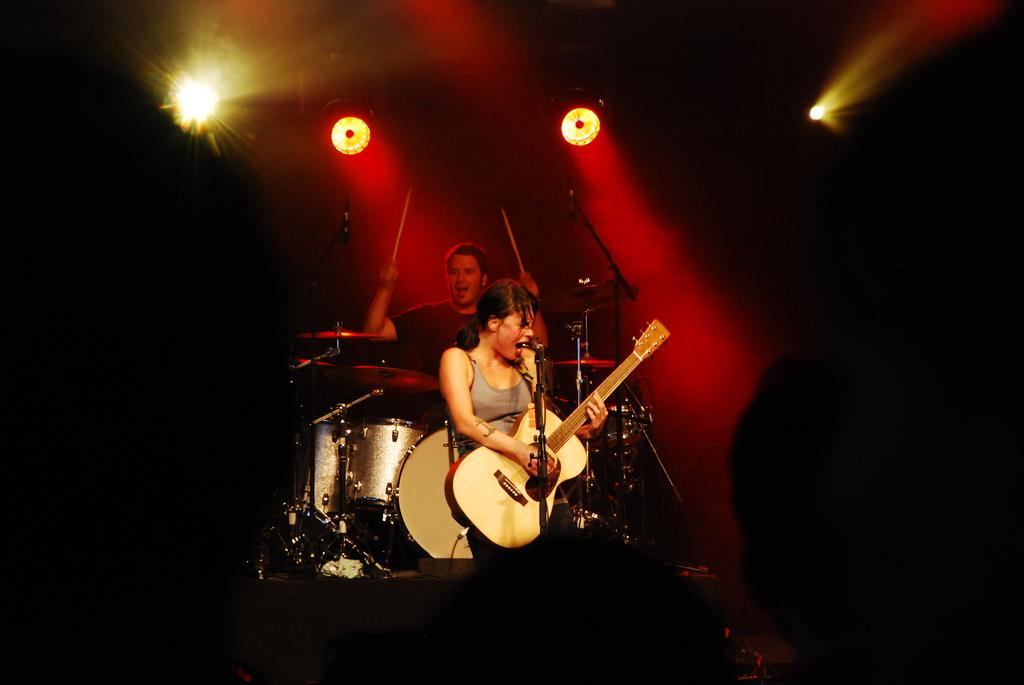What is the woman in the image doing? The woman is standing and singing, and she is holding a guitar. Can you describe the person in the image? The person is holding sticks and playing musical drums. What can be seen in the background of the image? There are lights visible in the image. What type of pancake is the woman wearing in the image? There is no pancake present in the image, and the woman is not wearing any clothing made of pancakes. 